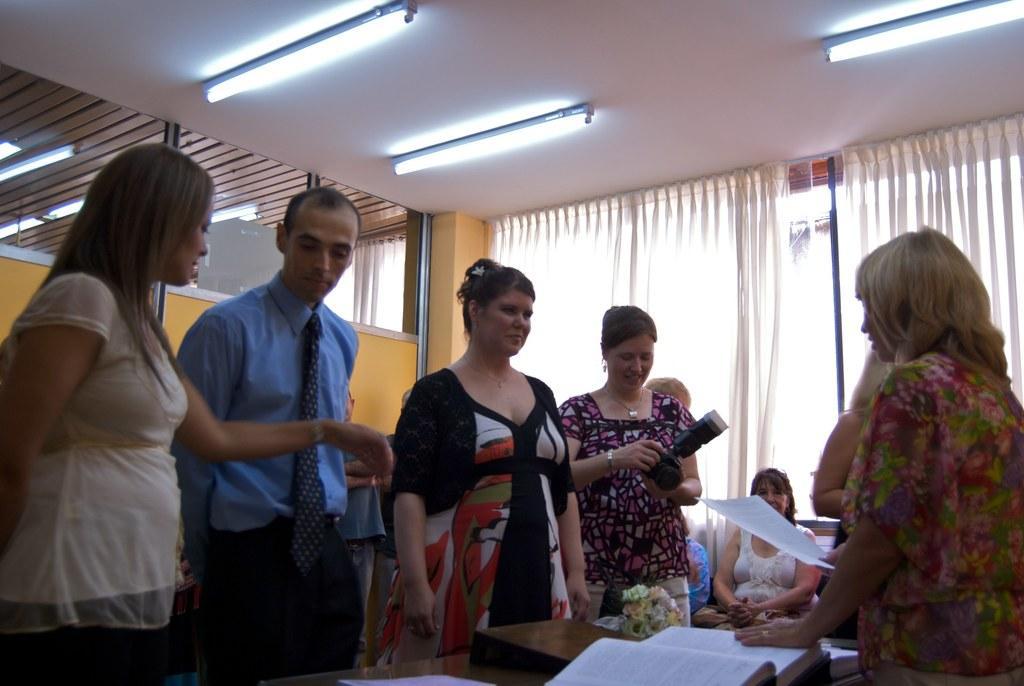Describe this image in one or two sentences. Here we can see few persons and she is holding a camera. This is a table. On the table there are books and a flower vase. She is holding a paper with her hands. In the background we can see curtains, glasses, and lights. 